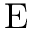<formula> <loc_0><loc_0><loc_500><loc_500>E</formula> 